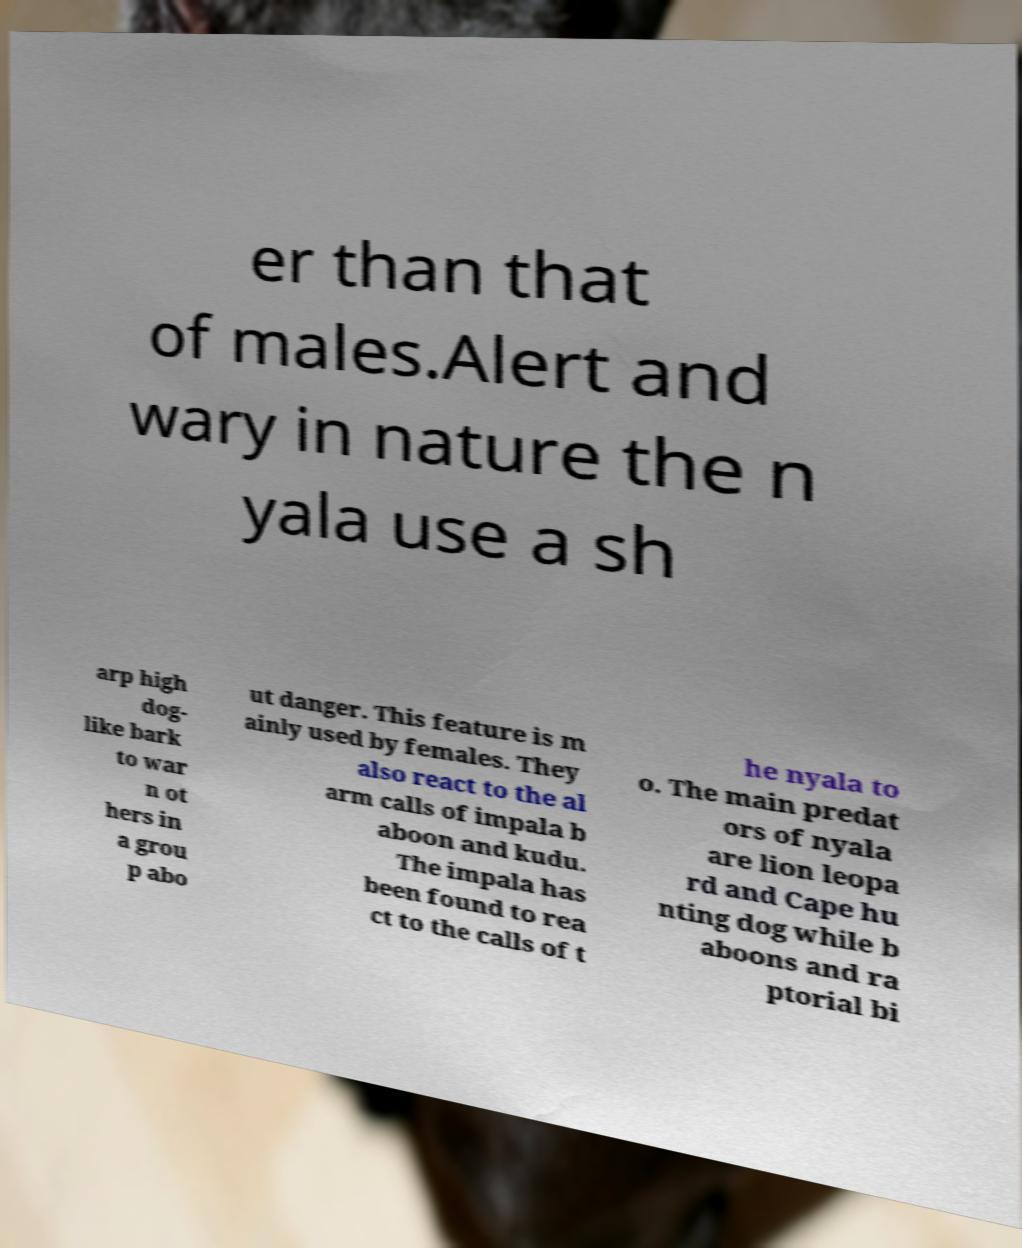What messages or text are displayed in this image? I need them in a readable, typed format. er than that of males.Alert and wary in nature the n yala use a sh arp high dog- like bark to war n ot hers in a grou p abo ut danger. This feature is m ainly used by females. They also react to the al arm calls of impala b aboon and kudu. The impala has been found to rea ct to the calls of t he nyala to o. The main predat ors of nyala are lion leopa rd and Cape hu nting dog while b aboons and ra ptorial bi 